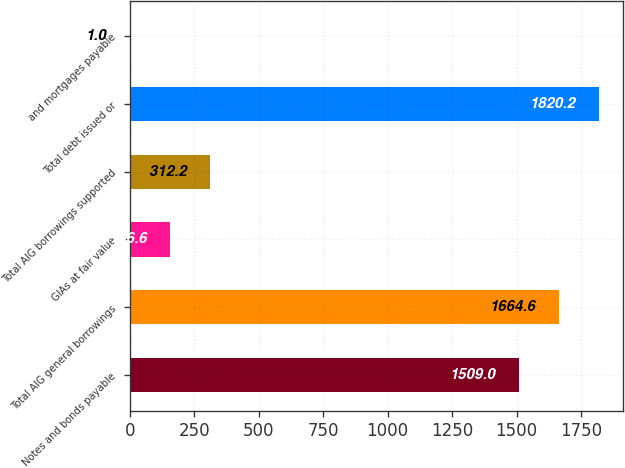Convert chart. <chart><loc_0><loc_0><loc_500><loc_500><bar_chart><fcel>Notes and bonds payable<fcel>Total AIG general borrowings<fcel>GIAs at fair value<fcel>Total AIG borrowings supported<fcel>Total debt issued or<fcel>and mortgages payable<nl><fcel>1509<fcel>1664.6<fcel>156.6<fcel>312.2<fcel>1820.2<fcel>1<nl></chart> 